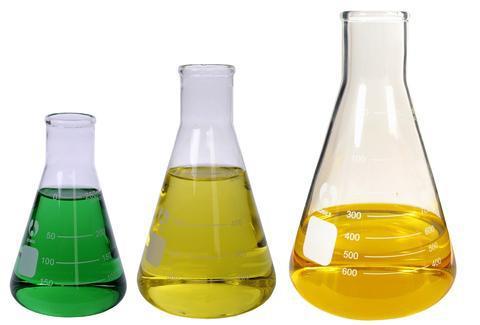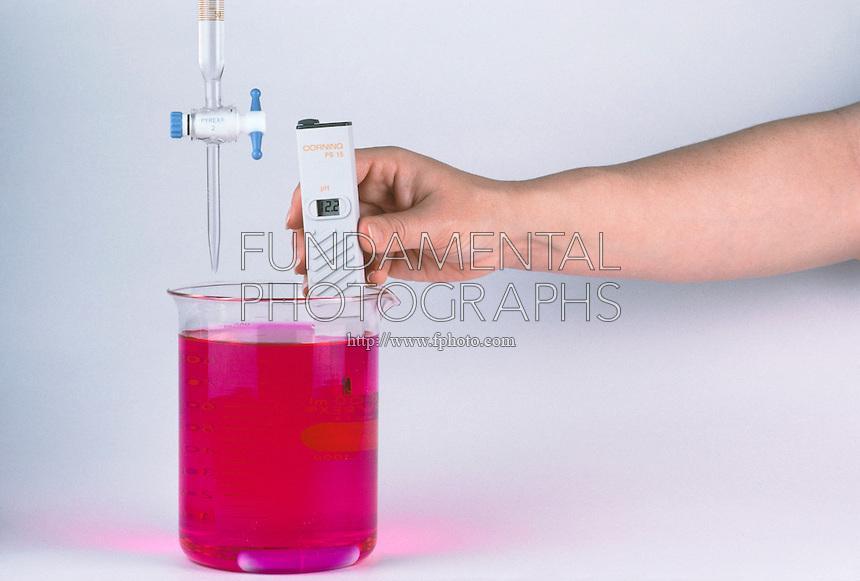The first image is the image on the left, the second image is the image on the right. For the images shown, is this caption "All images show beakers and all beakers contain colored liquids." true? Answer yes or no. Yes. The first image is the image on the left, the second image is the image on the right. Considering the images on both sides, is "There are no more than 5 laboratory flasks in the pair of images." valid? Answer yes or no. Yes. 